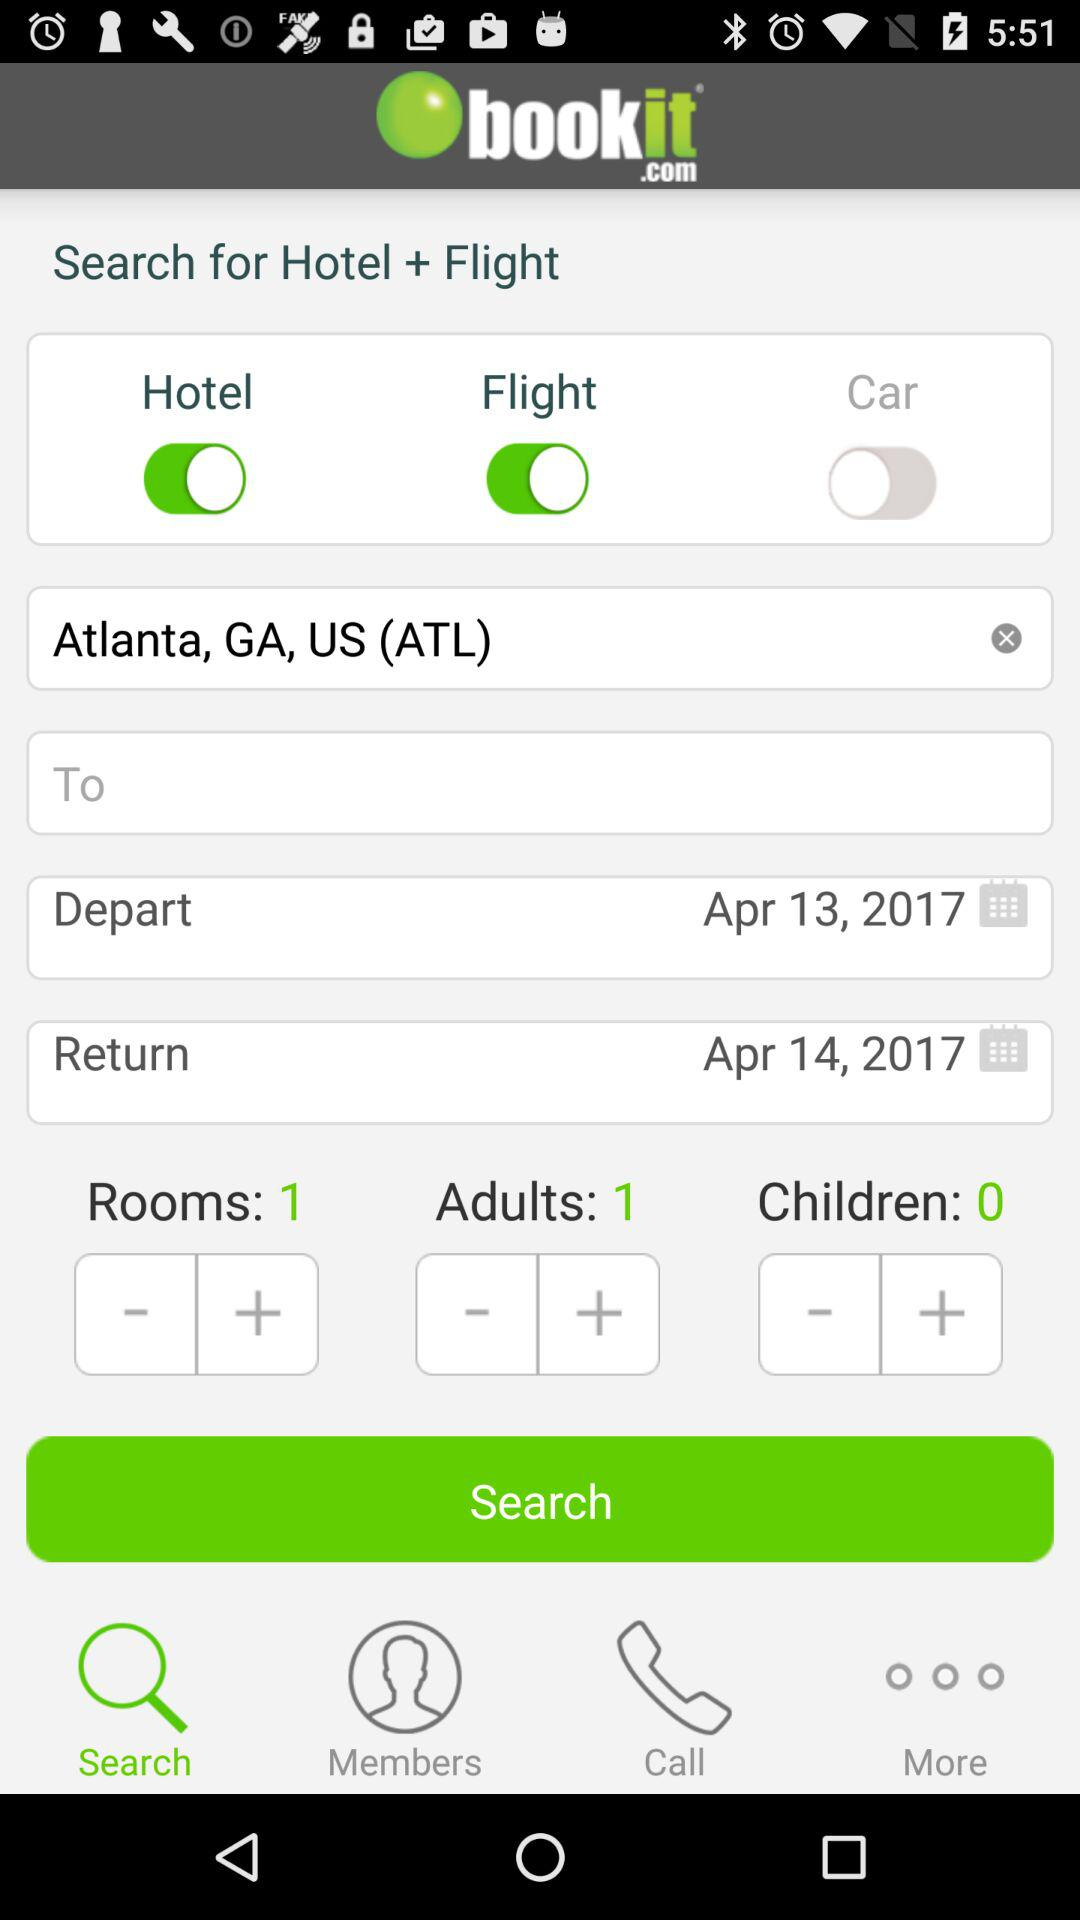What's the status for search?
When the provided information is insufficient, respond with <no answer>. <no answer> 